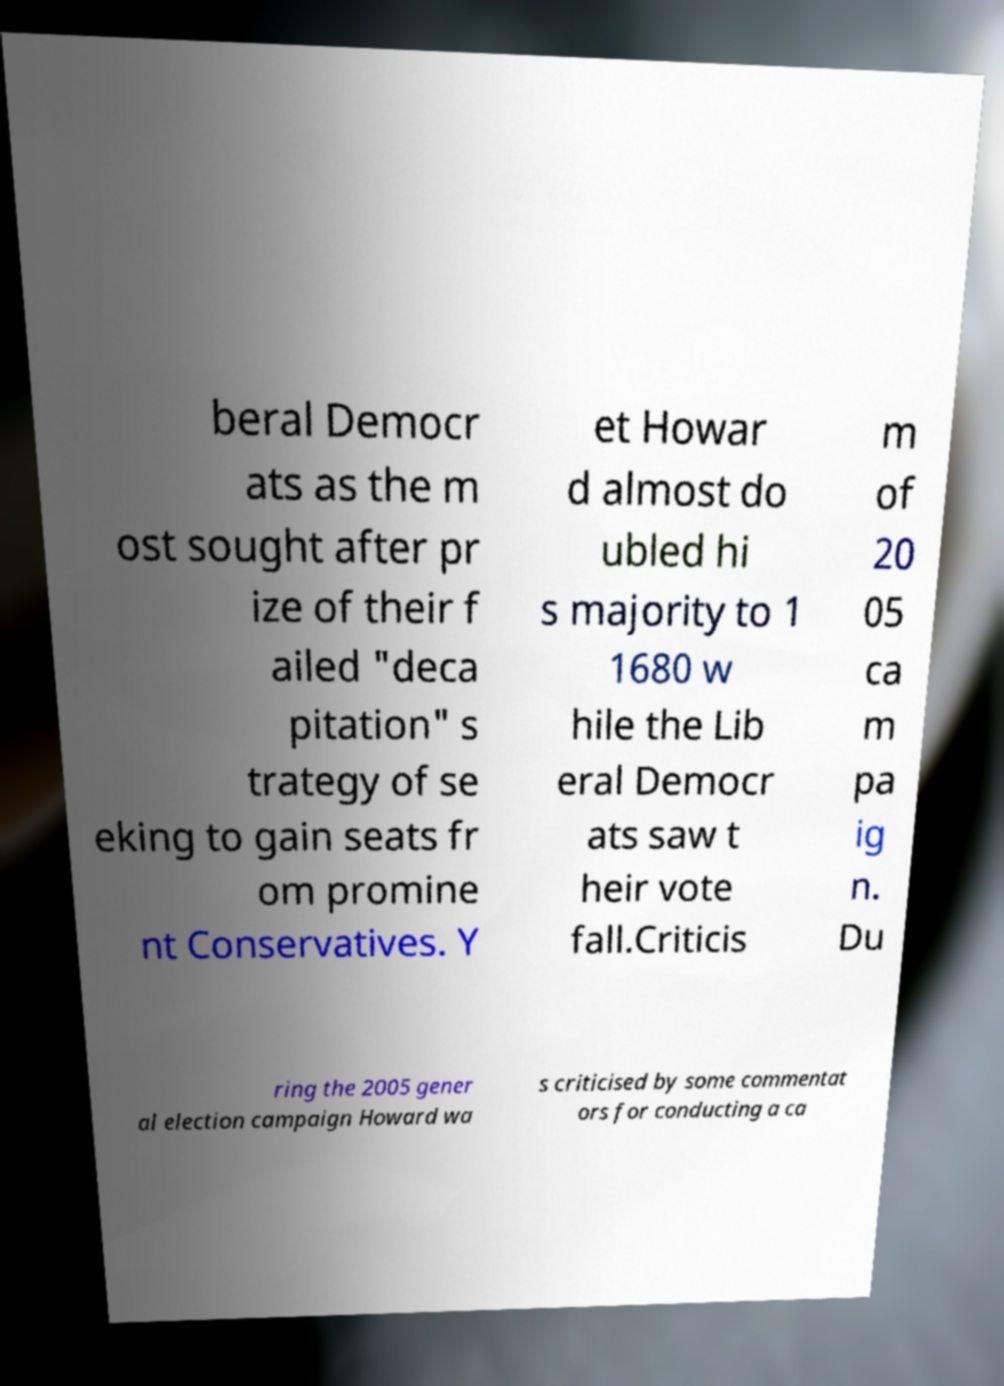I need the written content from this picture converted into text. Can you do that? beral Democr ats as the m ost sought after pr ize of their f ailed "deca pitation" s trategy of se eking to gain seats fr om promine nt Conservatives. Y et Howar d almost do ubled hi s majority to 1 1680 w hile the Lib eral Democr ats saw t heir vote fall.Criticis m of 20 05 ca m pa ig n. Du ring the 2005 gener al election campaign Howard wa s criticised by some commentat ors for conducting a ca 